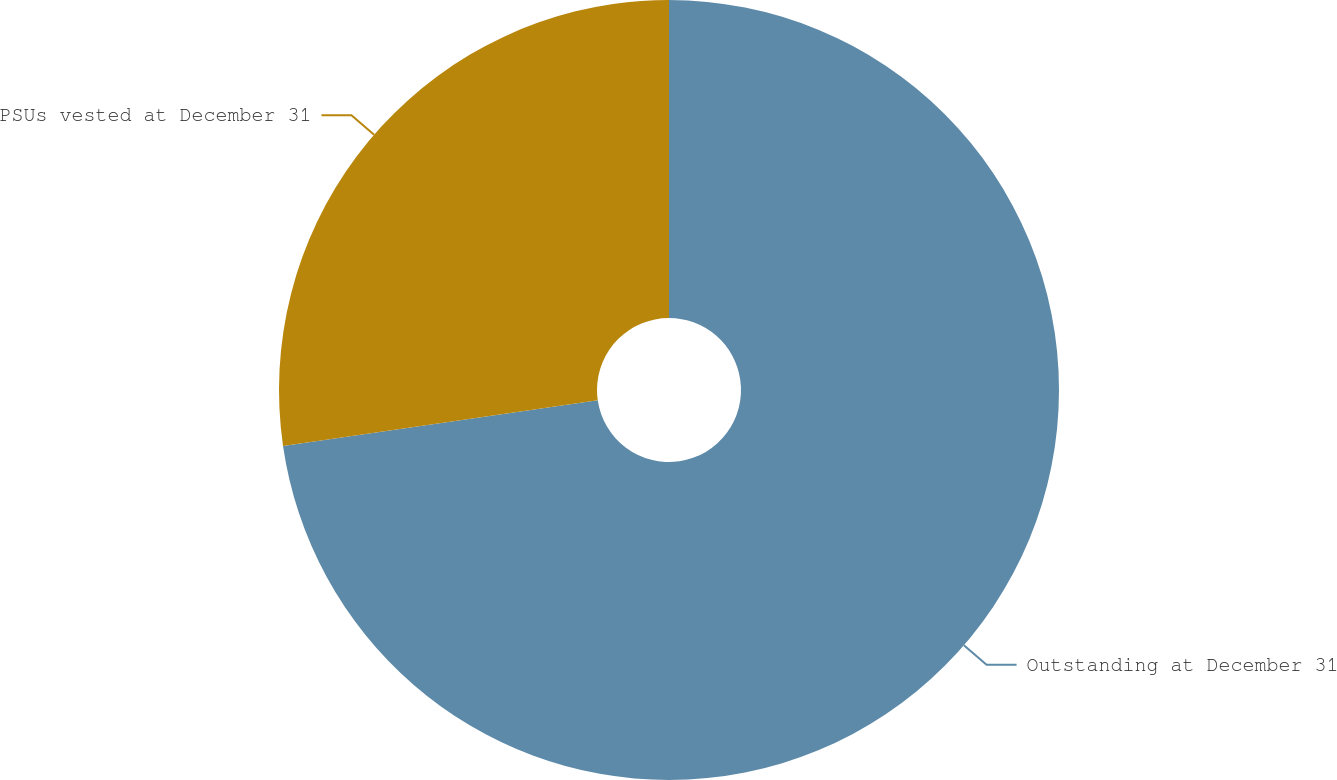Convert chart. <chart><loc_0><loc_0><loc_500><loc_500><pie_chart><fcel>Outstanding at December 31<fcel>PSUs vested at December 31<nl><fcel>72.71%<fcel>27.29%<nl></chart> 